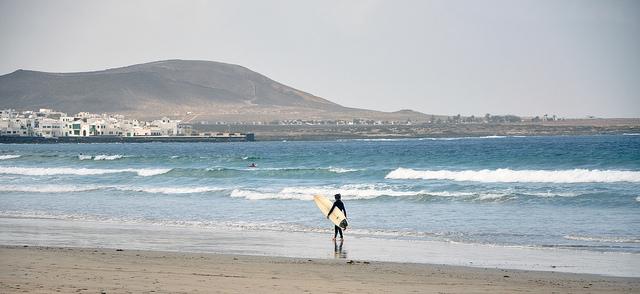Are there any houses nearby?
Short answer required. Yes. What is the person carrying?
Quick response, please. Surfboard. What time of day is it?
Be succinct. Afternoon. Is the person on the beach, alone?
Write a very short answer. Yes. How many boats are in the water?
Short answer required. 0. Is the picture taken at the mountains?
Short answer required. No. Is the water cold or hot?
Quick response, please. Cold. 